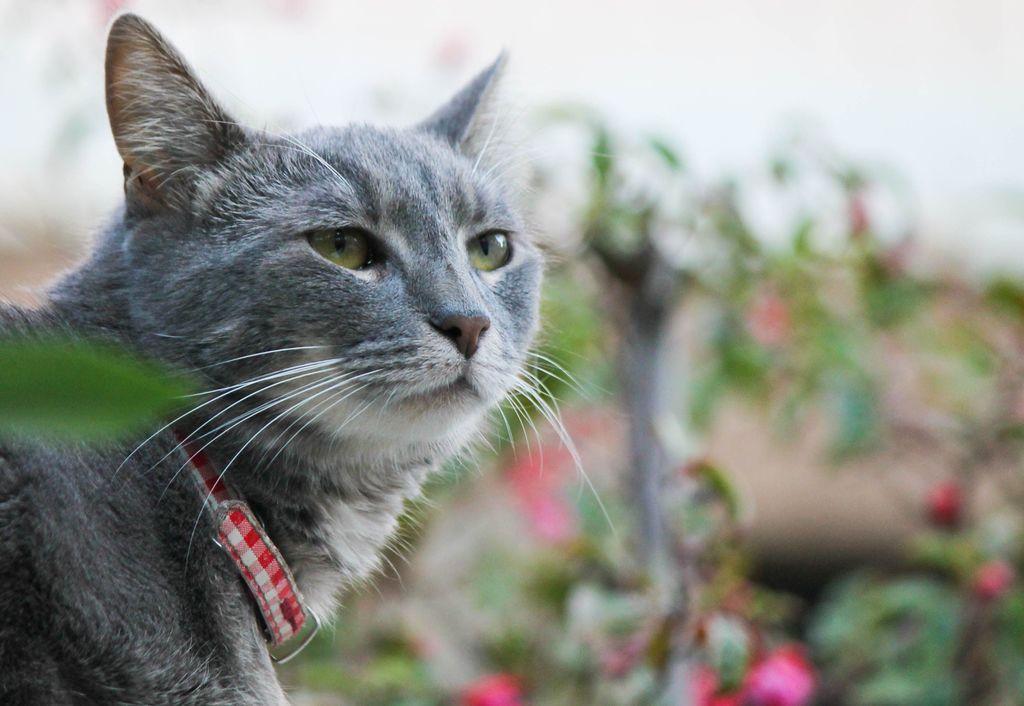In one or two sentences, can you explain what this image depicts? In this image there are flowers, plants and a cat. 